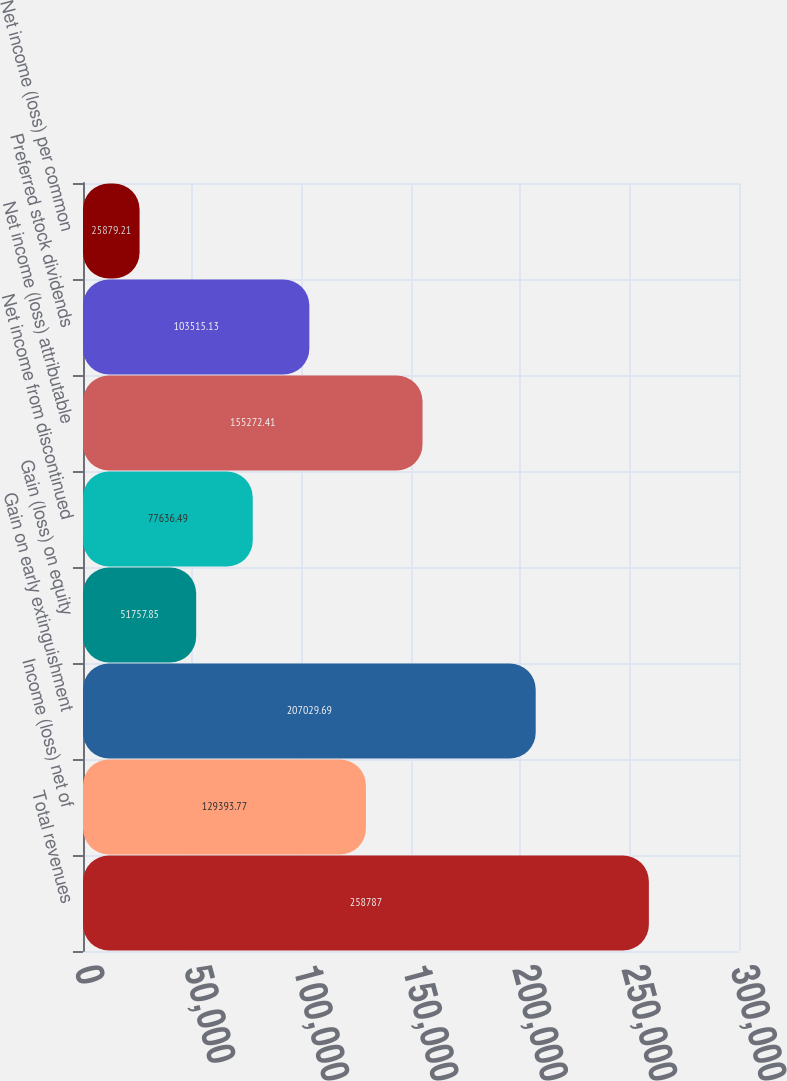Convert chart. <chart><loc_0><loc_0><loc_500><loc_500><bar_chart><fcel>Total revenues<fcel>Income (loss) net of<fcel>Gain on early extinguishment<fcel>Gain (loss) on equity<fcel>Net income from discontinued<fcel>Net income (loss) attributable<fcel>Preferred stock dividends<fcel>Net income (loss) per common<nl><fcel>258787<fcel>129394<fcel>207030<fcel>51757.8<fcel>77636.5<fcel>155272<fcel>103515<fcel>25879.2<nl></chart> 